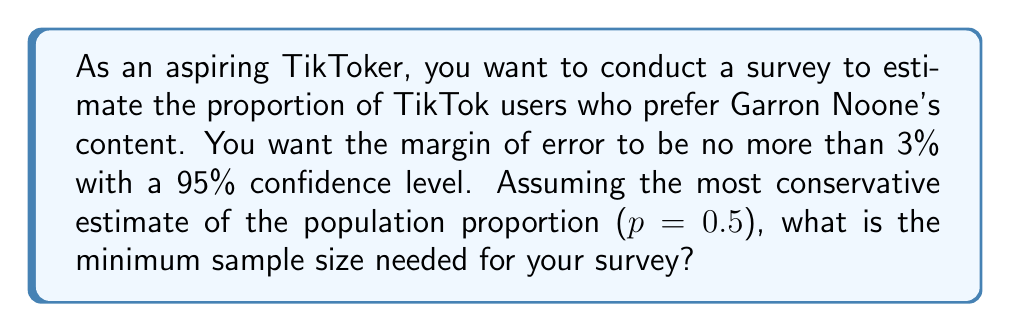Teach me how to tackle this problem. To determine the sample size needed for this survey, we'll use the formula for sample size calculation when estimating a population proportion:

$$n = \frac{z^2 \cdot p(1-p)}{E^2}$$

Where:
$n$ = sample size
$z$ = z-score for the desired confidence level
$p$ = estimated population proportion
$E$ = margin of error

Step 1: Determine the z-score for a 95% confidence level.
For a 95% confidence level, $z = 1.96$

Step 2: Use the most conservative estimate for the population proportion.
When the true proportion is unknown, we use $p = 0.5$ as it yields the largest sample size.

Step 3: Convert the margin of error to a decimal.
$E = 3\% = 0.03$

Step 4: Plug the values into the formula:

$$n = \frac{1.96^2 \cdot 0.5(1-0.5)}{0.03^2}$$

Step 5: Calculate the result:

$$n = \frac{3.8416 \cdot 0.25}{0.0009} = 1067.11$$

Step 6: Round up to the nearest whole number, as we can't survey a fraction of a person.

Therefore, the minimum sample size needed is 1068 TikTok users.
Answer: 1068 TikTok users 